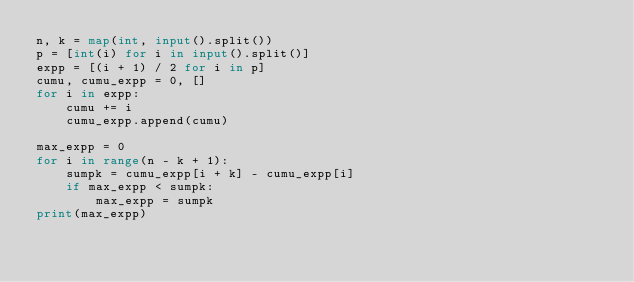Convert code to text. <code><loc_0><loc_0><loc_500><loc_500><_Python_>n, k = map(int, input().split())
p = [int(i) for i in input().split()]
expp = [(i + 1) / 2 for i in p]
cumu, cumu_expp = 0, []
for i in expp:
    cumu += i
    cumu_expp.append(cumu)

max_expp = 0
for i in range(n - k + 1):
    sumpk = cumu_expp[i + k] - cumu_expp[i]
    if max_expp < sumpk:
        max_expp = sumpk
print(max_expp)</code> 